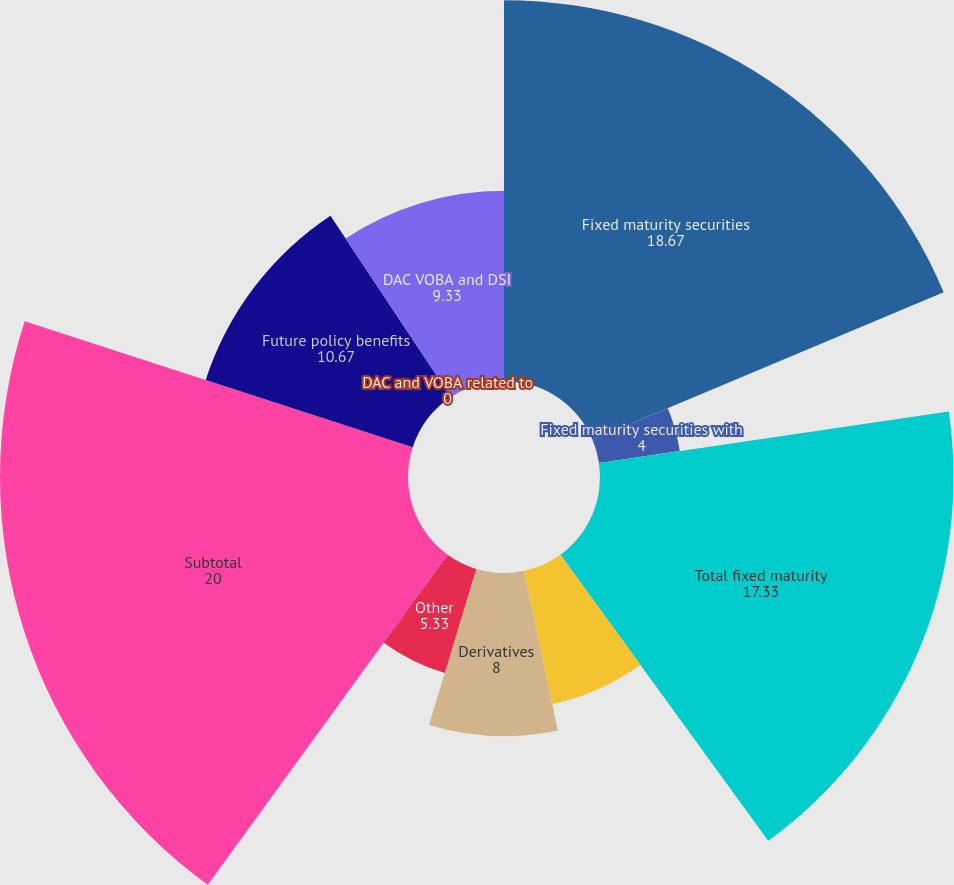Convert chart to OTSL. <chart><loc_0><loc_0><loc_500><loc_500><pie_chart><fcel>Fixed maturity securities<fcel>Fixed maturity securities with<fcel>Total fixed maturity<fcel>Equity securities<fcel>Derivatives<fcel>Other<fcel>Subtotal<fcel>Future policy benefits<fcel>DAC and VOBA related to<fcel>DAC VOBA and DSI<nl><fcel>18.67%<fcel>4.0%<fcel>17.33%<fcel>6.67%<fcel>8.0%<fcel>5.33%<fcel>20.0%<fcel>10.67%<fcel>0.0%<fcel>9.33%<nl></chart> 